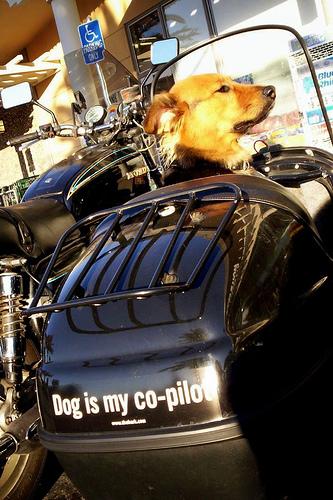What does the sticker say?
Concise answer only. Dog is my co-pilot. What kind of sign is in the background?
Quick response, please. Handicap. What animal is in the photo?
Keep it brief. Dog. 